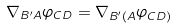<formula> <loc_0><loc_0><loc_500><loc_500>\nabla _ { B ^ { \prime } A } \varphi _ { C D } = \nabla _ { B ^ { \prime } ( A } \varphi _ { C D ) }</formula> 